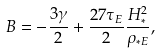Convert formula to latex. <formula><loc_0><loc_0><loc_500><loc_500>B = - \frac { 3 \gamma } { 2 } + \frac { 2 7 \tau _ { E } } { 2 } \frac { H _ { * } ^ { 2 } } { \rho _ { * E } } ,</formula> 